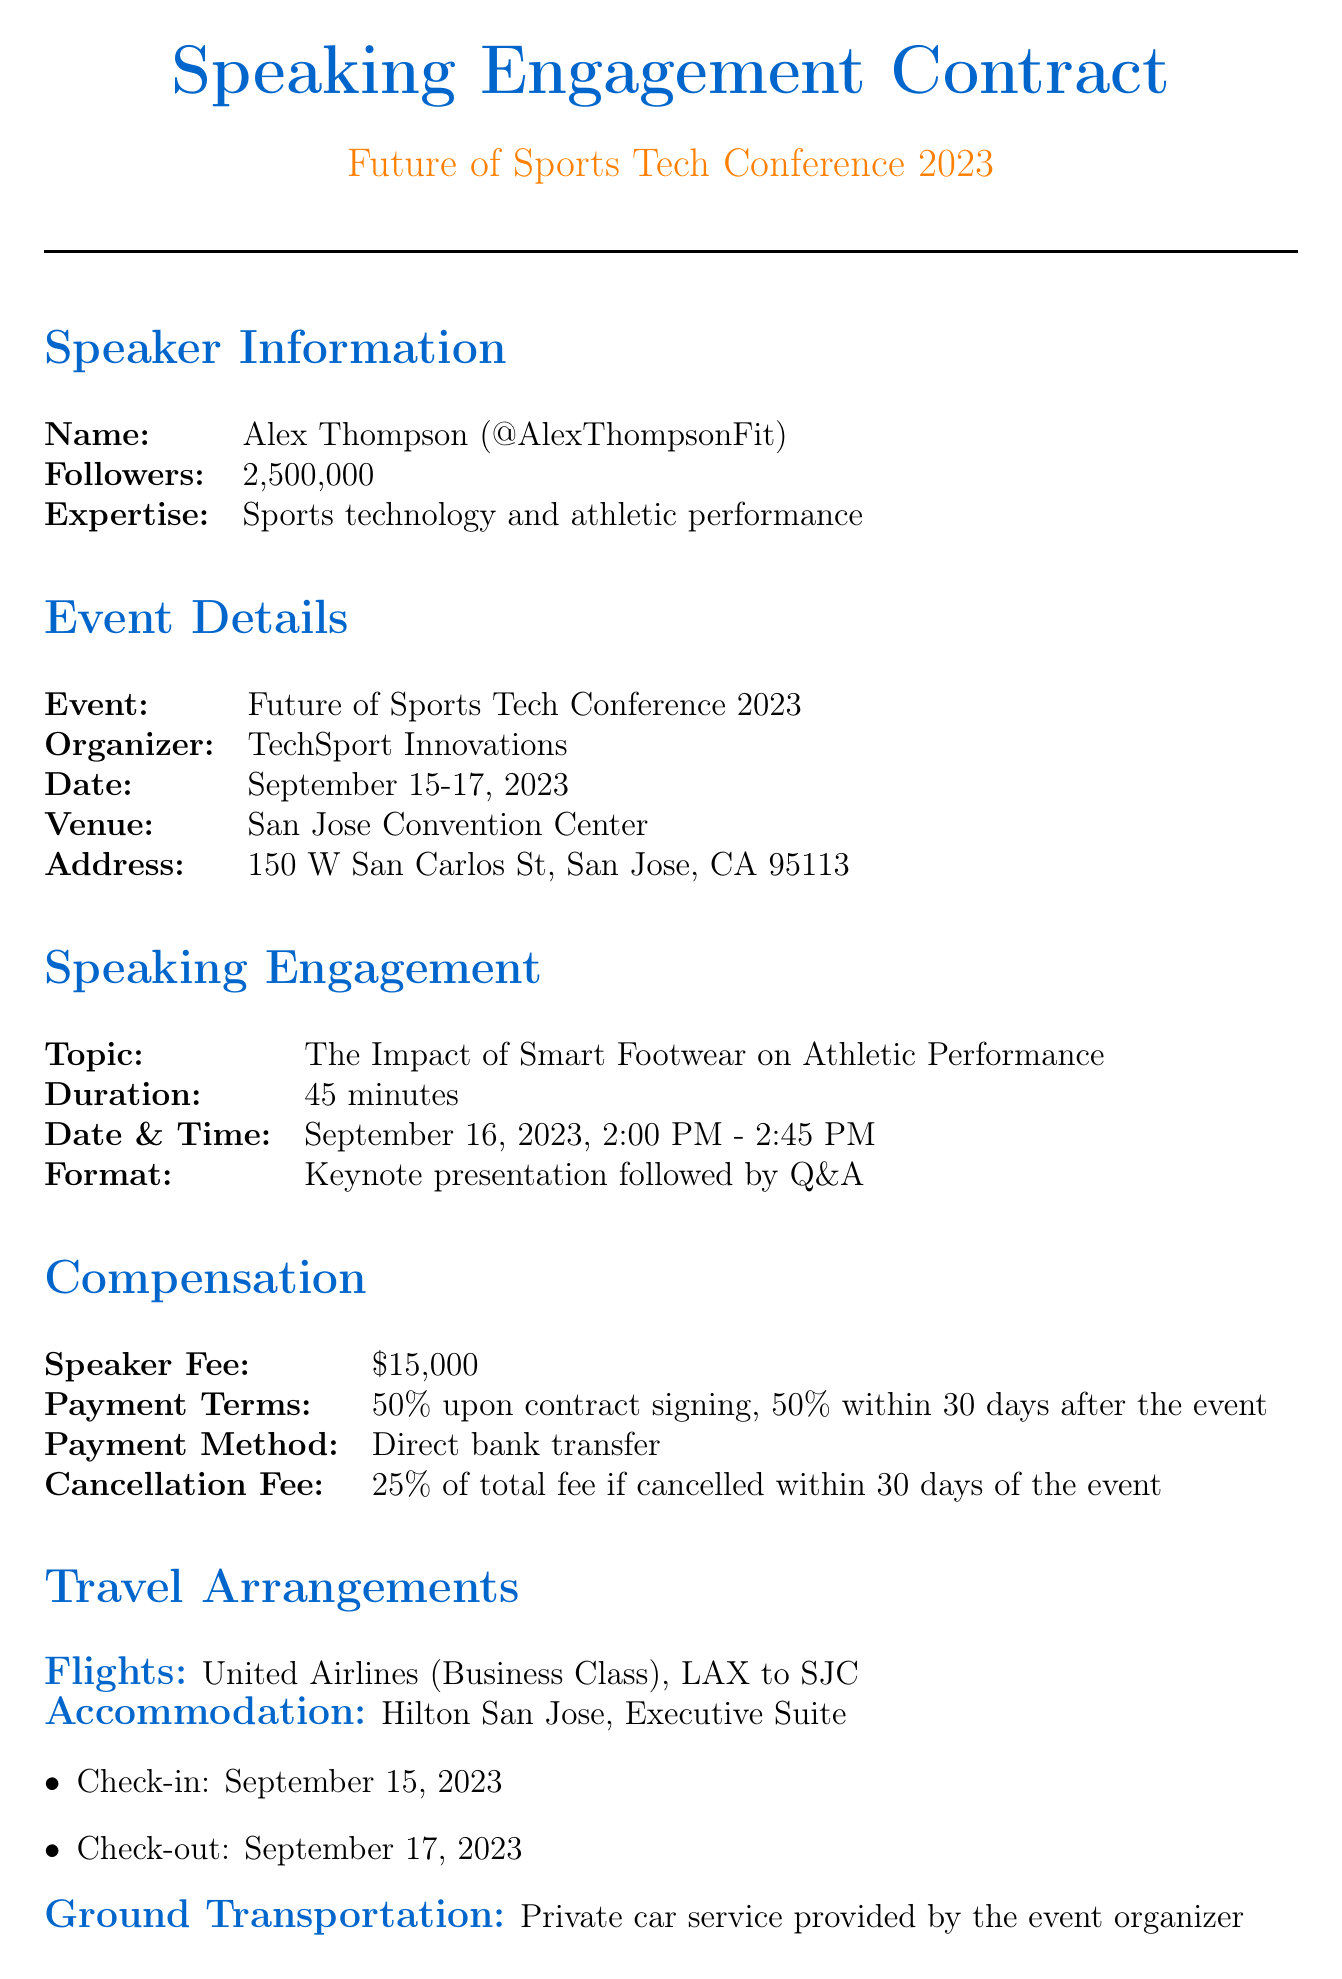what is the speaker's name? The speaker's name is presented clearly in the document under speaker information.
Answer: Alex Thompson what is the date of the speaking engagement? The speaking engagement date is specified in the document.
Answer: September 16, 2023 how much is the speaker fee? The document lists the total speaker fee.
Answer: $15,000 which airline is used for the flights? The airline for travel arrangements is mentioned explicitly in the document.
Answer: United Airlines what is the duration of the keynote presentation? The duration of the speaking engagement is mentioned under the speaking engagement section.
Answer: 45 minutes what is the cancellation fee percentage if the event is canceled within 30 days? The cancellation fee details are specified in the compensation section.
Answer: 25% who is the event coordinator? The contact information for the event coordinator is provided at the end of the document.
Answer: Sarah Chen what type of accommodation is provided? The document specifies the type of accommodation included in the travel arrangements.
Answer: Executive Suite what is the meal allowance per day? The meal allowance details are provided in the additional perks section of the document.
Answer: $150 per day 